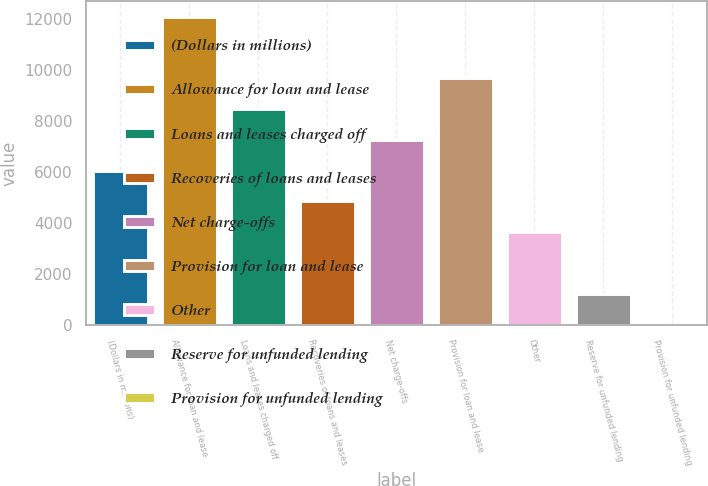Convert chart to OTSL. <chart><loc_0><loc_0><loc_500><loc_500><bar_chart><fcel>(Dollars in millions)<fcel>Allowance for loan and lease<fcel>Loans and leases charged off<fcel>Recoveries of loans and leases<fcel>Net charge-offs<fcel>Provision for loan and lease<fcel>Other<fcel>Reserve for unfunded lending<fcel>Provision for unfunded lending<nl><fcel>6067<fcel>12106<fcel>8482.6<fcel>4859.2<fcel>7274.8<fcel>9690.4<fcel>3651.4<fcel>1235.8<fcel>28<nl></chart> 